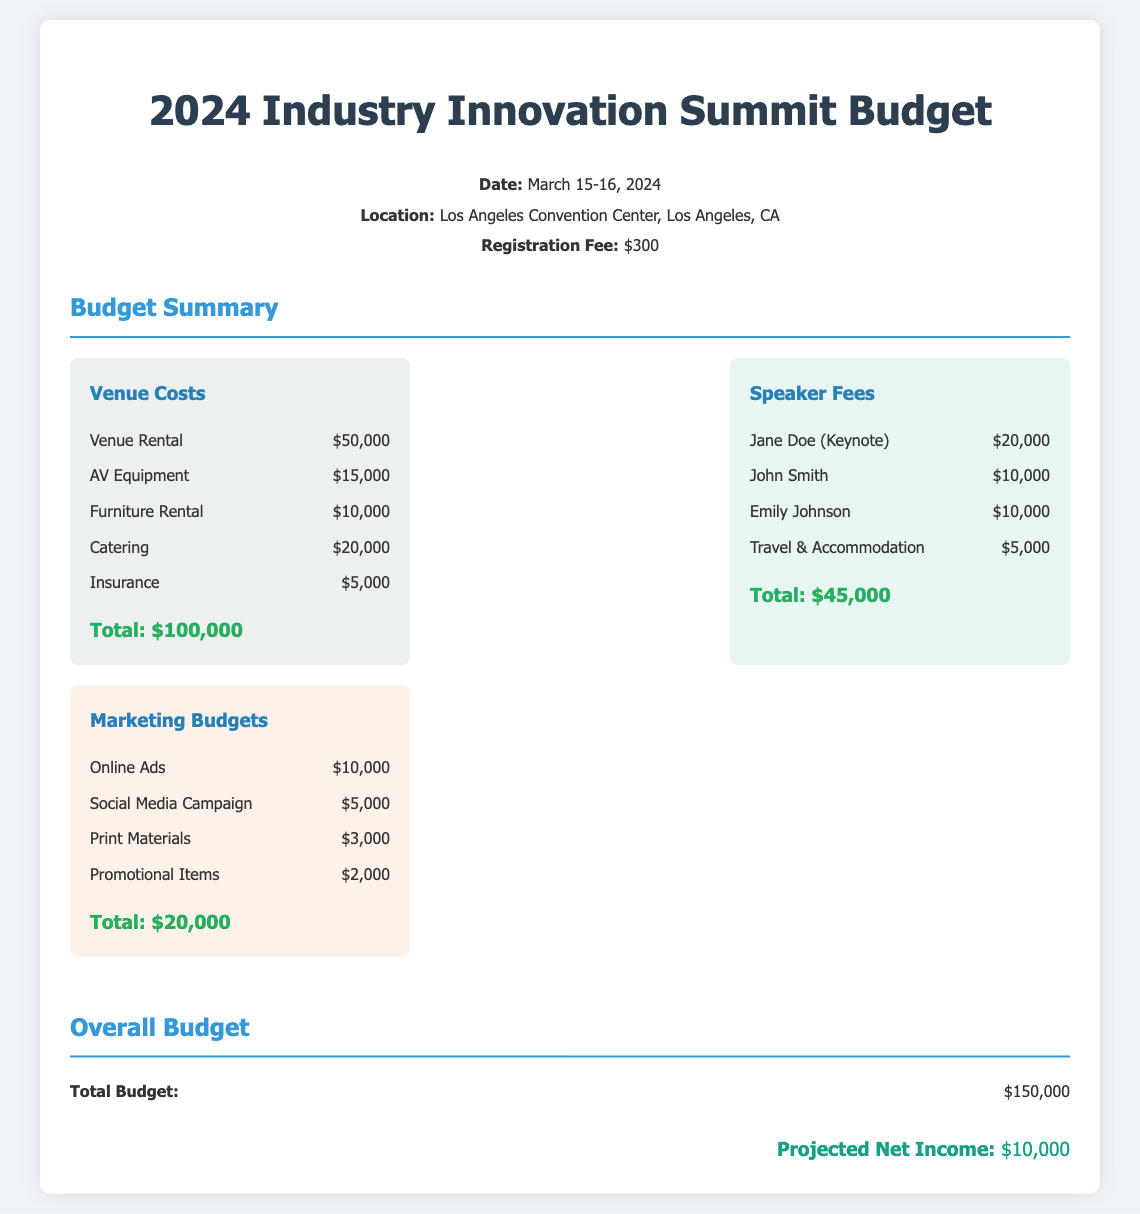What is the date of the conference? The conference will take place on March 15-16, 2024, as mentioned in the event details section.
Answer: March 15-16, 2024 What is the venue rental cost? The venue rental cost is listed in the Venue Costs section as $50,000.
Answer: $50,000 How much is the total budget? The total budget is summarized at the end of the document as $150,000.
Answer: $150,000 Who is the keynote speaker? The document identifies Jane Doe as the keynote speaker under the Speaker Fees section.
Answer: Jane Doe What is the total marketing budget? The total for the marketing budgets is provided at the end of the respective section as $20,000.
Answer: $20,000 What are the travel and accommodation costs for speakers? In the Speaker Fees section, Travel & Accommodation is noted as $5,000.
Answer: $5,000 How many speakers are listed in the budget? There are four speakers listed in the Speaker Fees section of the document.
Answer: Four What is the projected net income? The projected net income is stated at the bottom of the document as $10,000.
Answer: $10,000 Which category contains AV equipment costs? AV Equipment is included under the Venue Costs category according to the budget breakdown.
Answer: Venue Costs 